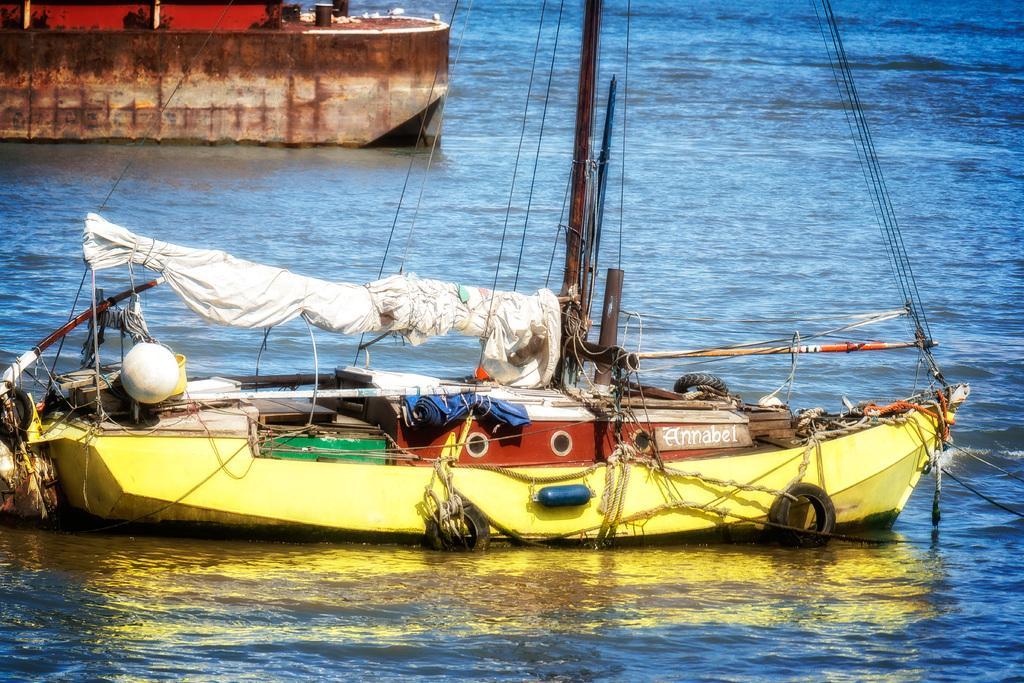Please provide a concise description of this image. In this image I can see few ships in different color. I can see wires,poles and few objects inside. I can see the water in blue color. 